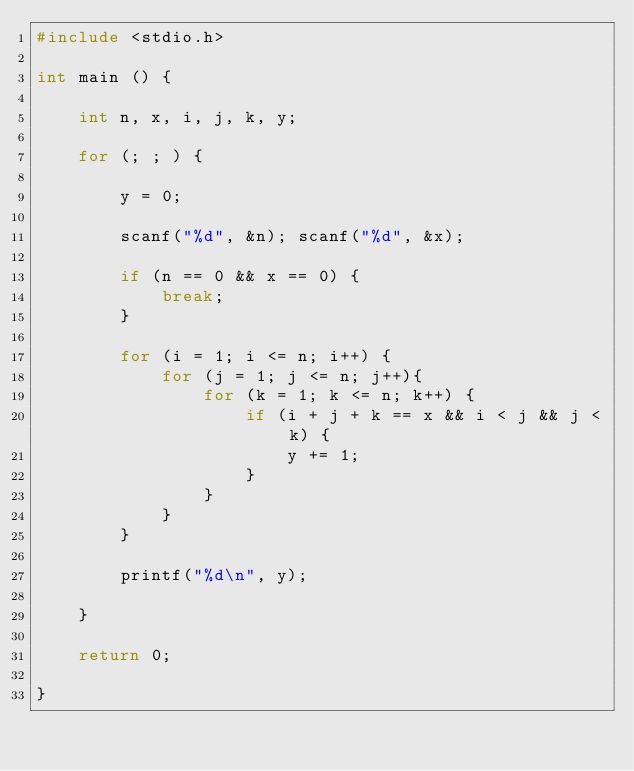Convert code to text. <code><loc_0><loc_0><loc_500><loc_500><_C_>#include <stdio.h>

int main () {

    int n, x, i, j, k, y;

    for (; ; ) {

        y = 0;

        scanf("%d", &n); scanf("%d", &x);

        if (n == 0 && x == 0) {
            break;
        }

        for (i = 1; i <= n; i++) {
            for (j = 1; j <= n; j++){
                for (k = 1; k <= n; k++) {
                    if (i + j + k == x && i < j && j < k) {
                        y += 1;
                    }
                }
            }
        }

        printf("%d\n", y);

    }

    return 0;

}

</code> 